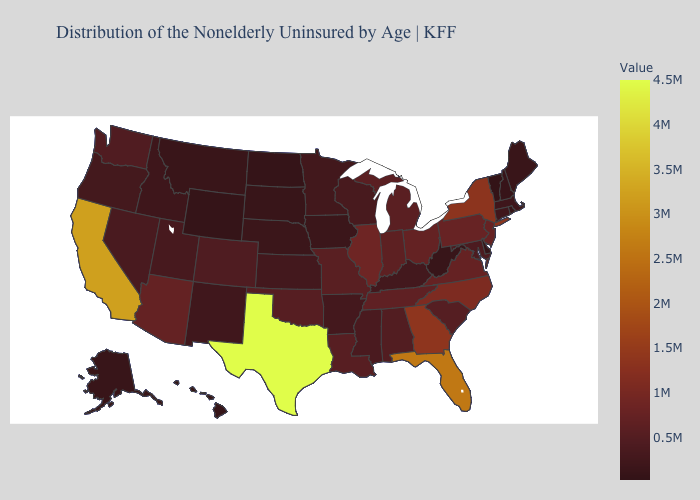Among the states that border New Jersey , which have the highest value?
Answer briefly. New York. Which states have the lowest value in the USA?
Keep it brief. Vermont. Which states have the lowest value in the USA?
Write a very short answer. Vermont. Which states have the lowest value in the USA?
Write a very short answer. Vermont. Does Ohio have the lowest value in the MidWest?
Be succinct. No. 